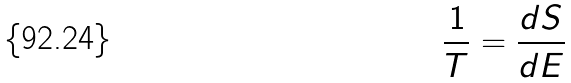Convert formula to latex. <formula><loc_0><loc_0><loc_500><loc_500>\frac { 1 } { T } = \frac { d S } { d E }</formula> 